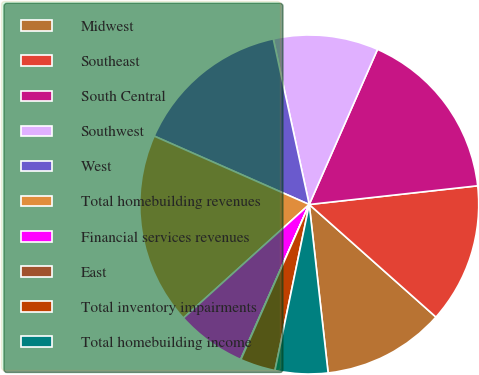Convert chart to OTSL. <chart><loc_0><loc_0><loc_500><loc_500><pie_chart><fcel>Midwest<fcel>Southeast<fcel>South Central<fcel>Southwest<fcel>West<fcel>Total homebuilding revenues<fcel>Financial services revenues<fcel>East<fcel>Total inventory impairments<fcel>Total homebuilding income<nl><fcel>11.66%<fcel>13.32%<fcel>16.64%<fcel>10.0%<fcel>14.98%<fcel>18.3%<fcel>6.68%<fcel>0.03%<fcel>3.36%<fcel>5.02%<nl></chart> 